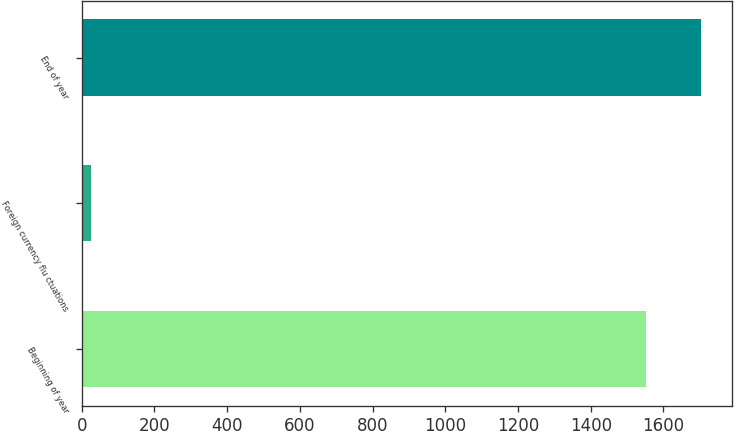<chart> <loc_0><loc_0><loc_500><loc_500><bar_chart><fcel>Beginning of year<fcel>Foreign currency flu ctuations<fcel>End of year<nl><fcel>1550.7<fcel>25.9<fcel>1703.21<nl></chart> 